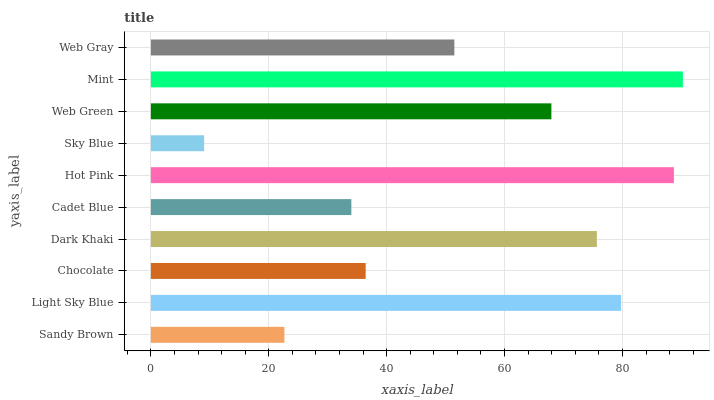Is Sky Blue the minimum?
Answer yes or no. Yes. Is Mint the maximum?
Answer yes or no. Yes. Is Light Sky Blue the minimum?
Answer yes or no. No. Is Light Sky Blue the maximum?
Answer yes or no. No. Is Light Sky Blue greater than Sandy Brown?
Answer yes or no. Yes. Is Sandy Brown less than Light Sky Blue?
Answer yes or no. Yes. Is Sandy Brown greater than Light Sky Blue?
Answer yes or no. No. Is Light Sky Blue less than Sandy Brown?
Answer yes or no. No. Is Web Green the high median?
Answer yes or no. Yes. Is Web Gray the low median?
Answer yes or no. Yes. Is Web Gray the high median?
Answer yes or no. No. Is Sky Blue the low median?
Answer yes or no. No. 